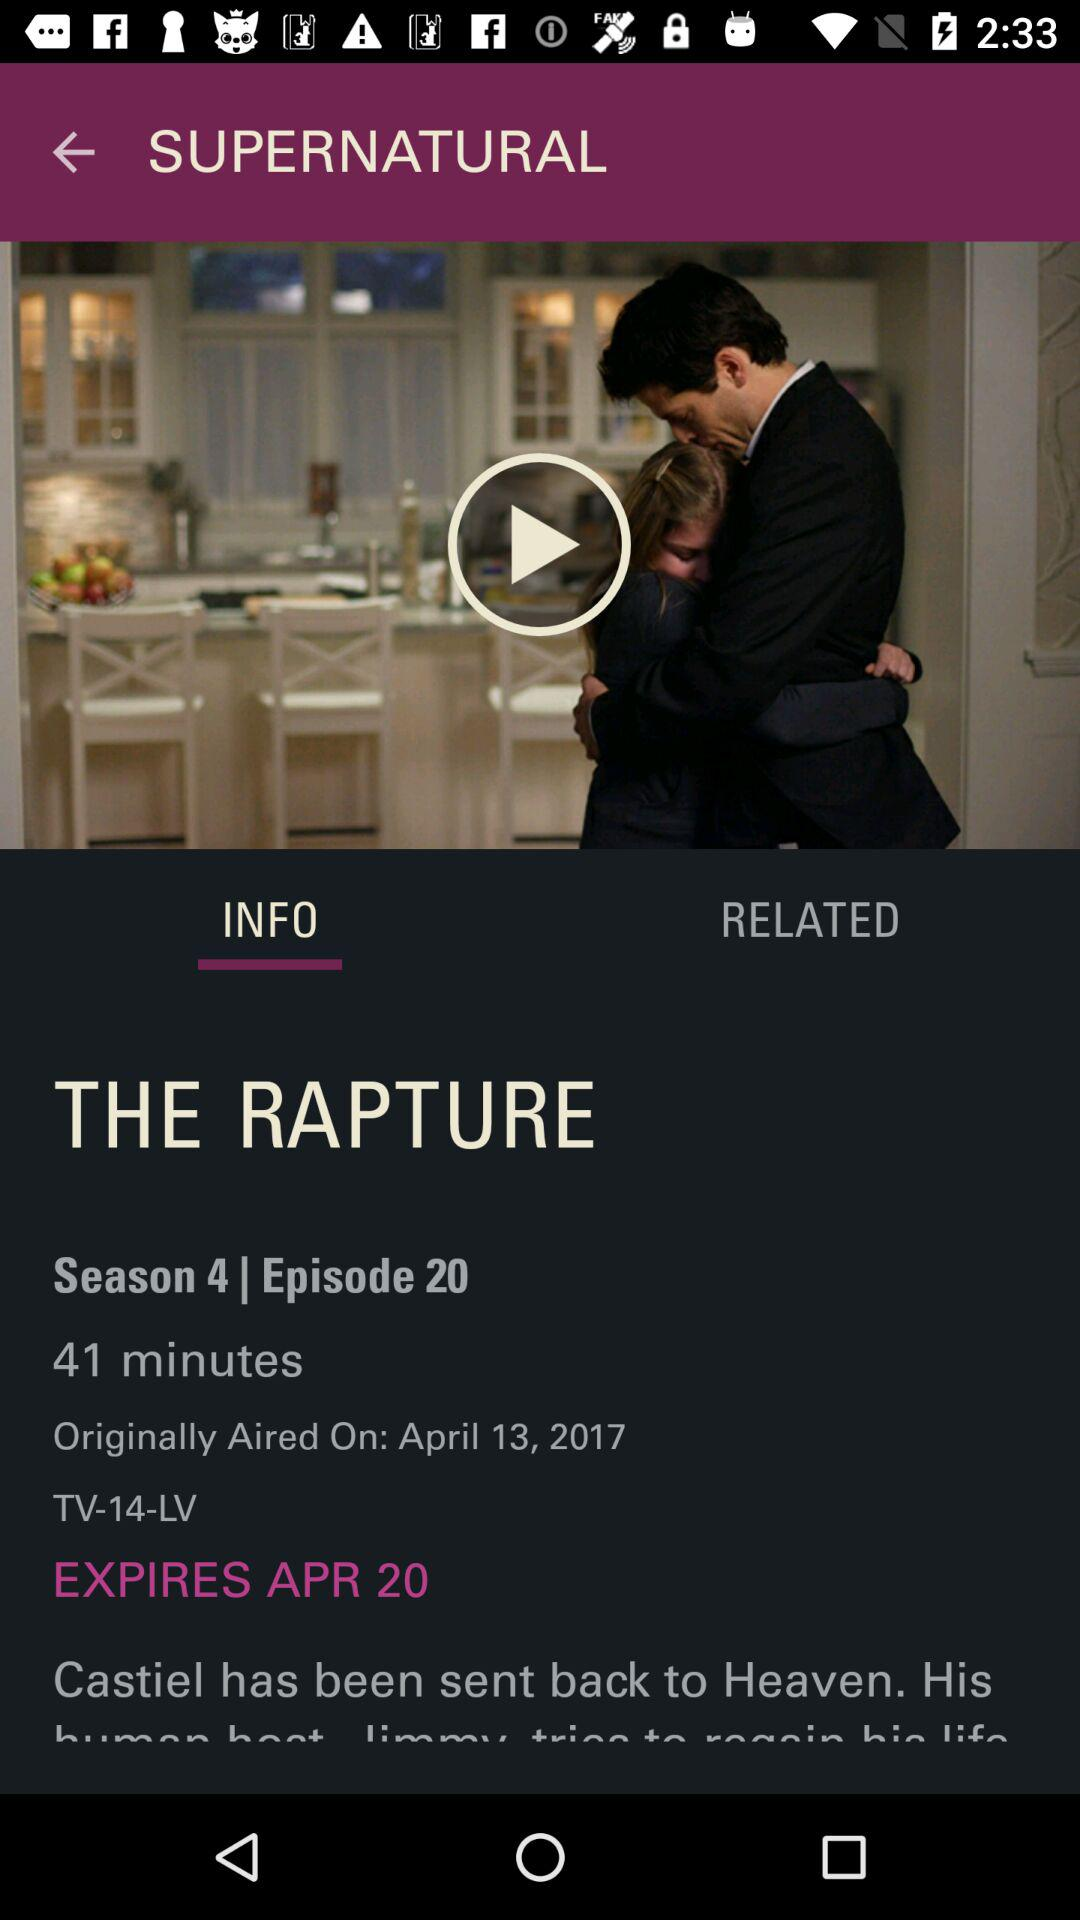How long is the episode?
Answer the question using a single word or phrase. 41 minutes 